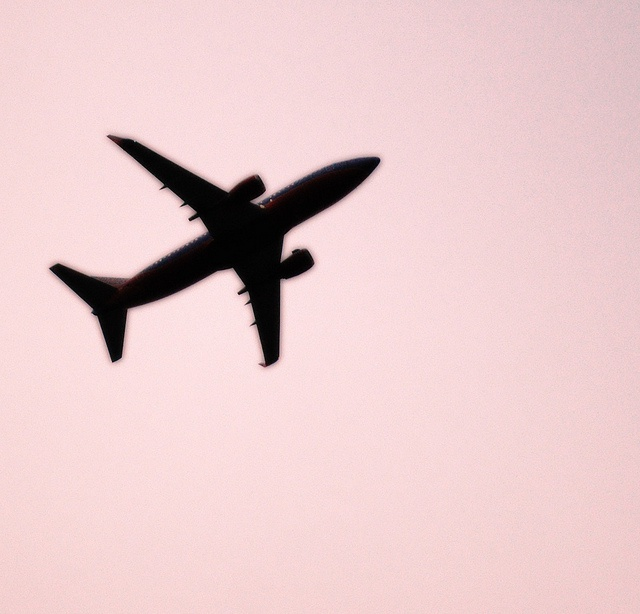Describe the objects in this image and their specific colors. I can see a airplane in pink, black, and darkgray tones in this image. 